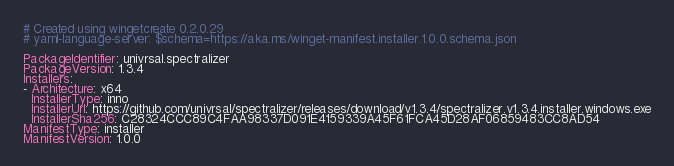Convert code to text. <code><loc_0><loc_0><loc_500><loc_500><_YAML_># Created using wingetcreate 0.2.0.29
# yaml-language-server: $schema=https://aka.ms/winget-manifest.installer.1.0.0.schema.json

PackageIdentifier: univrsal.spectralizer
PackageVersion: 1.3.4
Installers:
- Architecture: x64
  InstallerType: inno
  InstallerUrl: https://github.com/univrsal/spectralizer/releases/download/v1.3.4/spectralizer.v1.3.4.installer.windows.exe
  InstallerSha256: C28324CCC89C4FAA98337D091E4159339A45F61FCA45D28AF06859483CC8AD54
ManifestType: installer
ManifestVersion: 1.0.0

</code> 